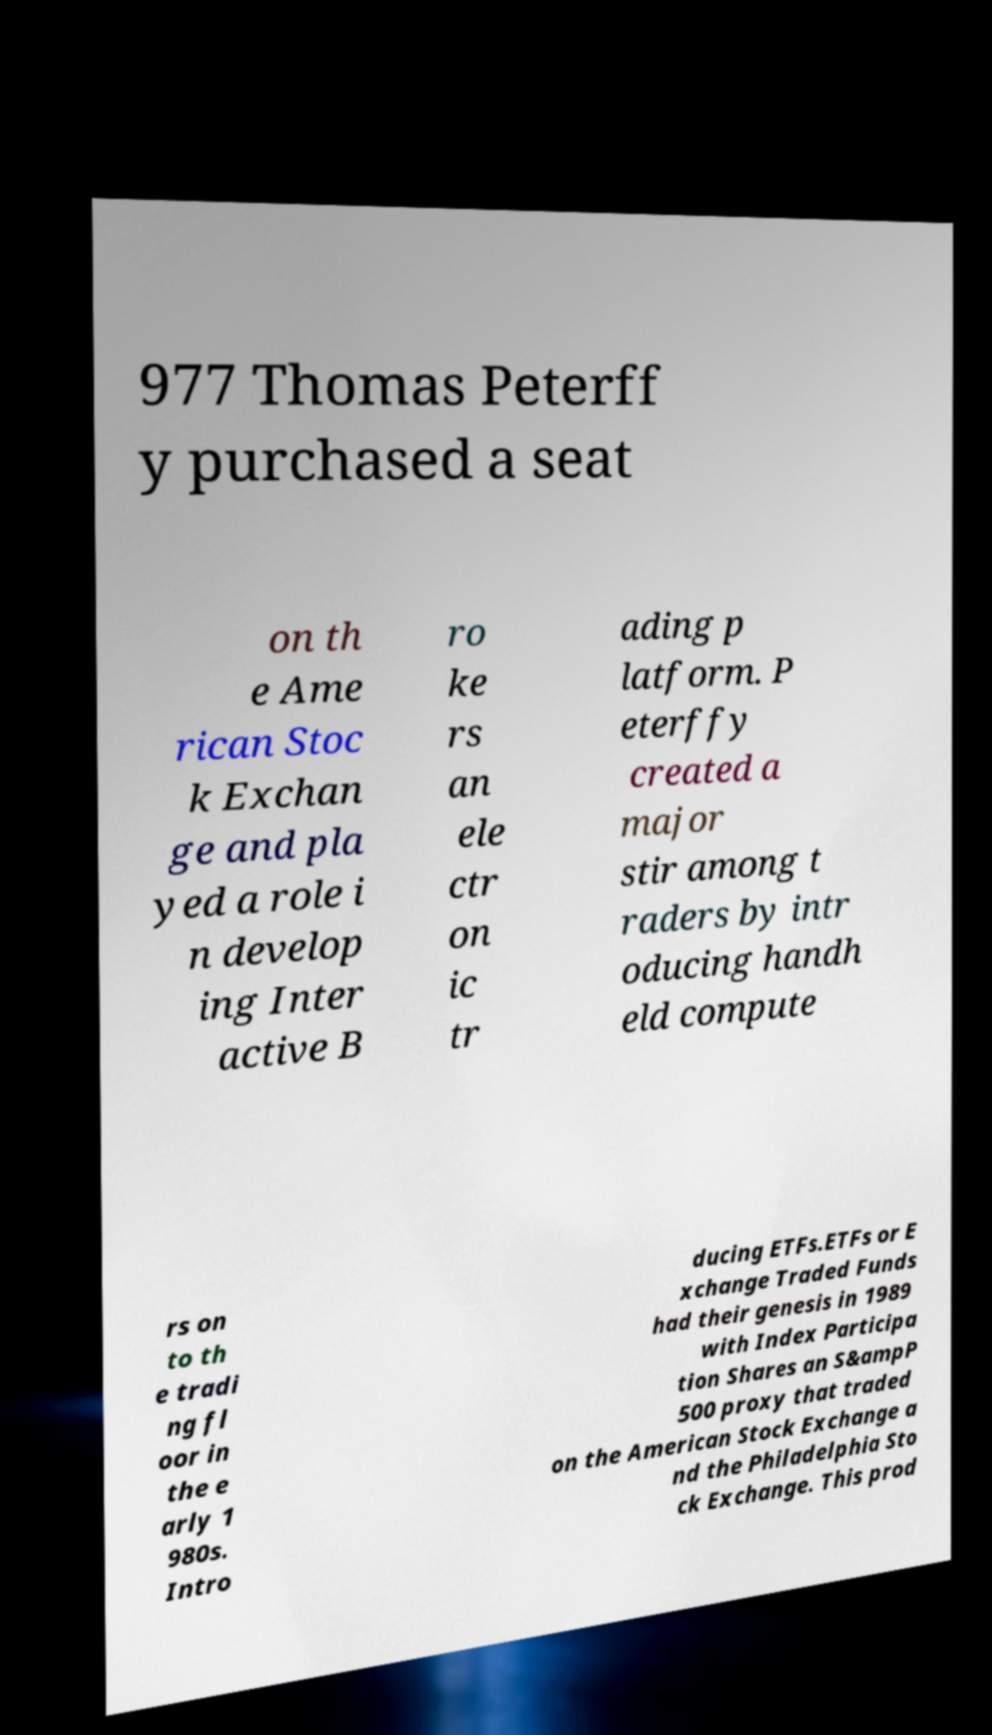For documentation purposes, I need the text within this image transcribed. Could you provide that? 977 Thomas Peterff y purchased a seat on th e Ame rican Stoc k Exchan ge and pla yed a role i n develop ing Inter active B ro ke rs an ele ctr on ic tr ading p latform. P eterffy created a major stir among t raders by intr oducing handh eld compute rs on to th e tradi ng fl oor in the e arly 1 980s. Intro ducing ETFs.ETFs or E xchange Traded Funds had their genesis in 1989 with Index Participa tion Shares an S&ampP 500 proxy that traded on the American Stock Exchange a nd the Philadelphia Sto ck Exchange. This prod 